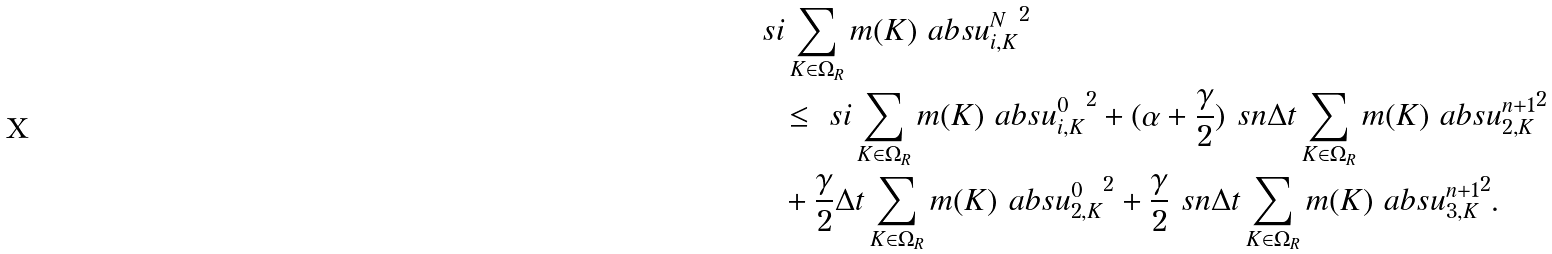Convert formula to latex. <formula><loc_0><loc_0><loc_500><loc_500>& \ s i \sum _ { K \in \Omega _ { R } } m ( K ) \ a b s { u ^ { N } _ { i , K } } ^ { 2 } \\ & \quad \leq \ s i \sum _ { K \in \Omega _ { R } } m ( K ) \ a b s { u ^ { 0 } _ { i , K } } ^ { 2 } + ( \alpha + \frac { \gamma } { 2 } ) \ s n \Delta t \sum _ { K \in \Omega _ { R } } m ( K ) \ a b s { u ^ { n + 1 } _ { 2 , K } } ^ { 2 } \\ & \quad + \frac { \gamma } { 2 } \Delta t \sum _ { K \in \Omega _ { R } } m ( K ) \ a b s { u ^ { 0 } _ { 2 , K } } ^ { 2 } + \frac { \gamma } { 2 } \ s n \Delta t \sum _ { K \in \Omega _ { R } } m ( K ) \ a b s { u ^ { n + 1 } _ { 3 , K } } ^ { 2 } .</formula> 